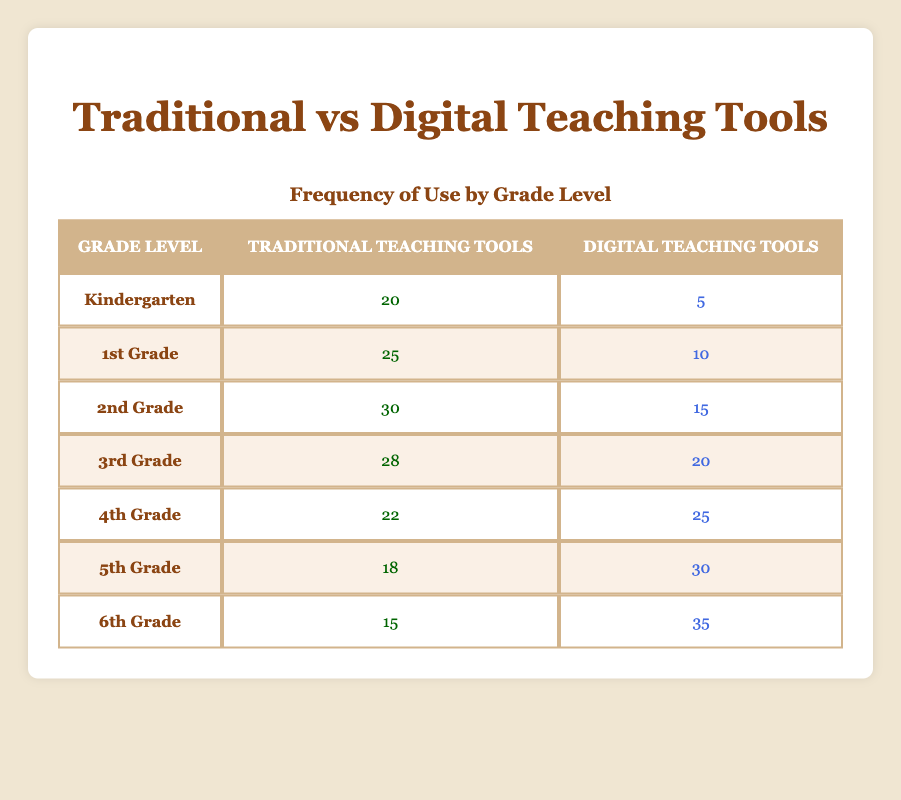What is the total frequency of traditional teaching tools used across all grade levels? To find the total frequency, we need to sum the values in the "Traditional Teaching Tools" column: 20 + 25 + 30 + 28 + 22 + 18 + 15 = 168.
Answer: 168 What is the difference between the highest and the lowest usage of digital teaching tools? The highest usage of digital tools is 35 (6th Grade) and the lowest is 5 (Kindergarten). The difference is 35 - 5 = 30.
Answer: 30 Is the frequency of traditional teaching tools used in 4th Grade more than in 2nd Grade? The frequency for 4th Grade is 22 and for 2nd Grade, it is 30. Since 22 is not greater than 30, the answer is no.
Answer: No In which grade level is the proportion of traditional teaching tools to digital teaching tools the highest? To find the proportion for each grade, we need to calculate the ratio of traditional to digital tools for each and compare: Kindergarten = 20/5 = 4; 1st Grade = 25/10 = 2.5; 2nd Grade = 30/15 = 2; 3rd Grade = 28/20 = 1.4; 4th Grade = 22/25 = 0.88; 5th Grade = 18/30 = 0.6; 6th Grade = 15/35 = 0.43. The highest proportion is in Kindergarten at 4.
Answer: Kindergarten What is the average frequency of digital teaching tools used across all grade levels? There are 7 grades, and the sum of digital tool usage is 5 + 10 + 15 + 20 + 25 + 30 + 35 = 140. To find the average: 140 / 7 = 20.
Answer: 20 Is there any grade level where the number of digital teaching tools used is higher than traditional teaching tools? Looking at the data, for the 5th Grade (Digital = 30, Traditional = 18) and 6th Grade (Digital = 35, Traditional = 15), both have higher digital tool usage than traditional. So, the answer is yes.
Answer: Yes What percentage of teaching tools used in 1st Grade are traditional? To find the percentage of traditional tools in 1st Grade, we calculate: (Traditional tools 25 / Total tools (25 + 10 = 35)) * 100 = (25/35) * 100, which simplifies to approximately 71.43%.
Answer: 71.43% Which grade level has the highest total frequency of teaching tools used? To find the total frequency for each grade, we add traditional and digital: Kindergarten: 25, 1st Grade: 35, 2nd Grade: 45, 3rd Grade: 48, 4th Grade: 47, 5th Grade: 48, 6th Grade: 50. The highest total is for 6th Grade with 50.
Answer: 6th Grade How many more traditional teaching tools are used in 2nd Grade compared to 4th Grade? In 2nd Grade, there are 30 traditional tools, and in 4th Grade, there are 22. The difference is 30 - 22 = 8.
Answer: 8 